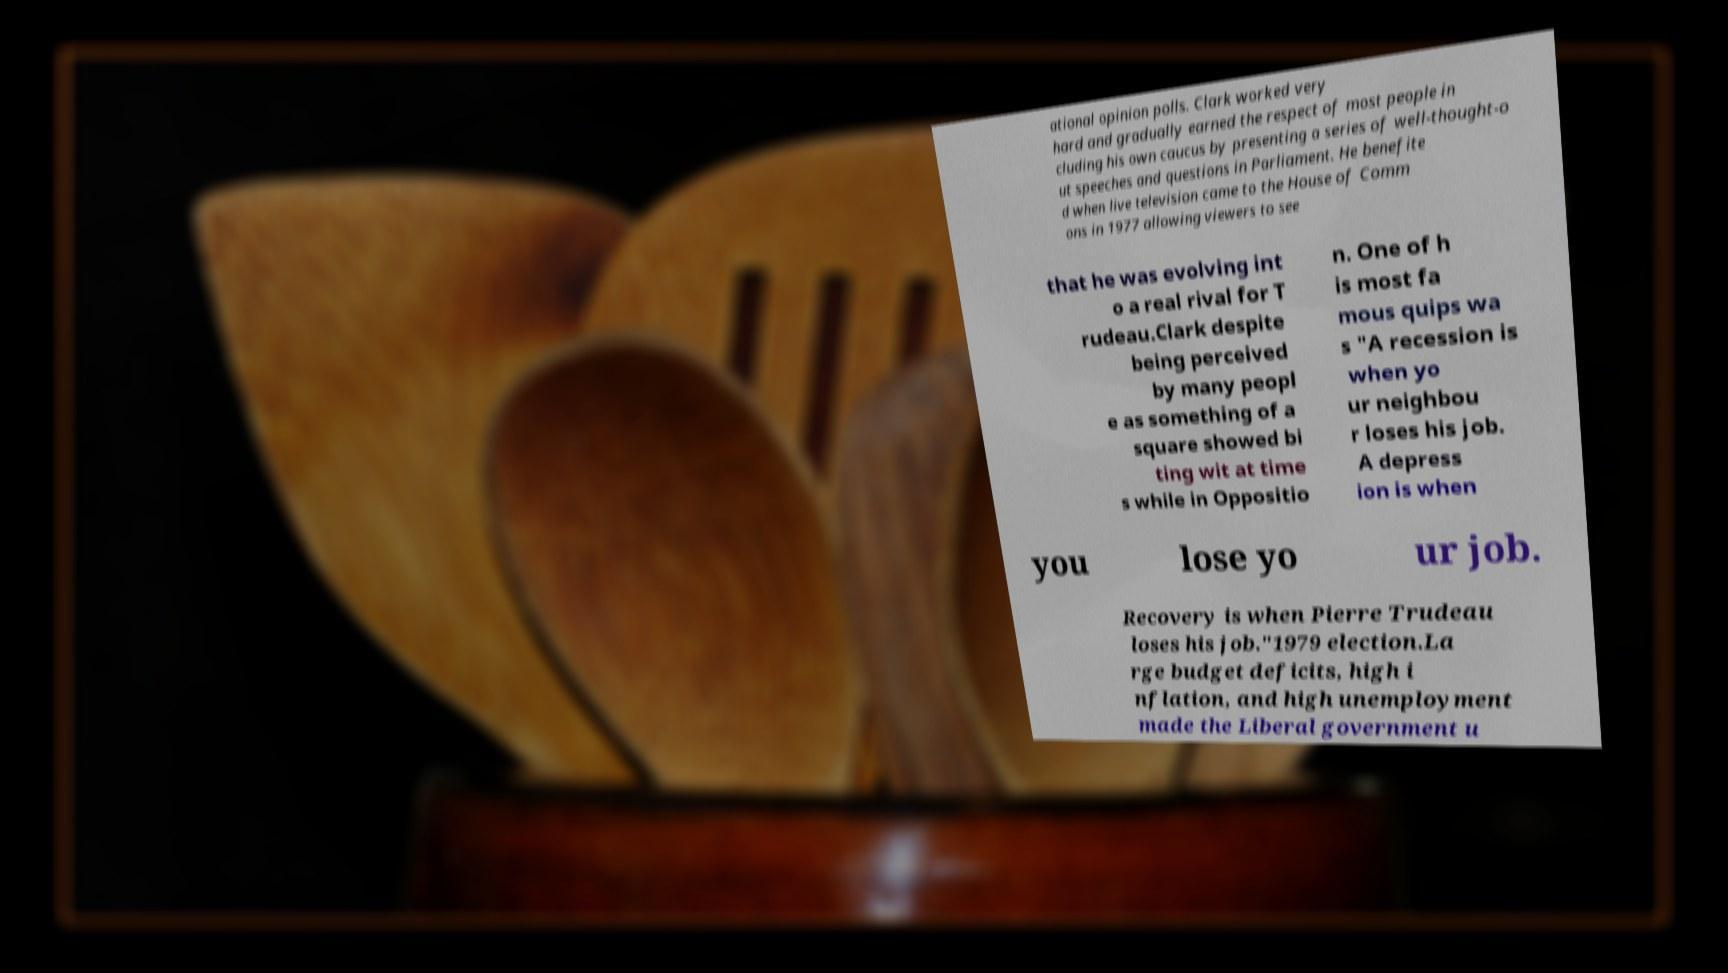Can you accurately transcribe the text from the provided image for me? ational opinion polls. Clark worked very hard and gradually earned the respect of most people in cluding his own caucus by presenting a series of well-thought-o ut speeches and questions in Parliament. He benefite d when live television came to the House of Comm ons in 1977 allowing viewers to see that he was evolving int o a real rival for T rudeau.Clark despite being perceived by many peopl e as something of a square showed bi ting wit at time s while in Oppositio n. One of h is most fa mous quips wa s "A recession is when yo ur neighbou r loses his job. A depress ion is when you lose yo ur job. Recovery is when Pierre Trudeau loses his job."1979 election.La rge budget deficits, high i nflation, and high unemployment made the Liberal government u 